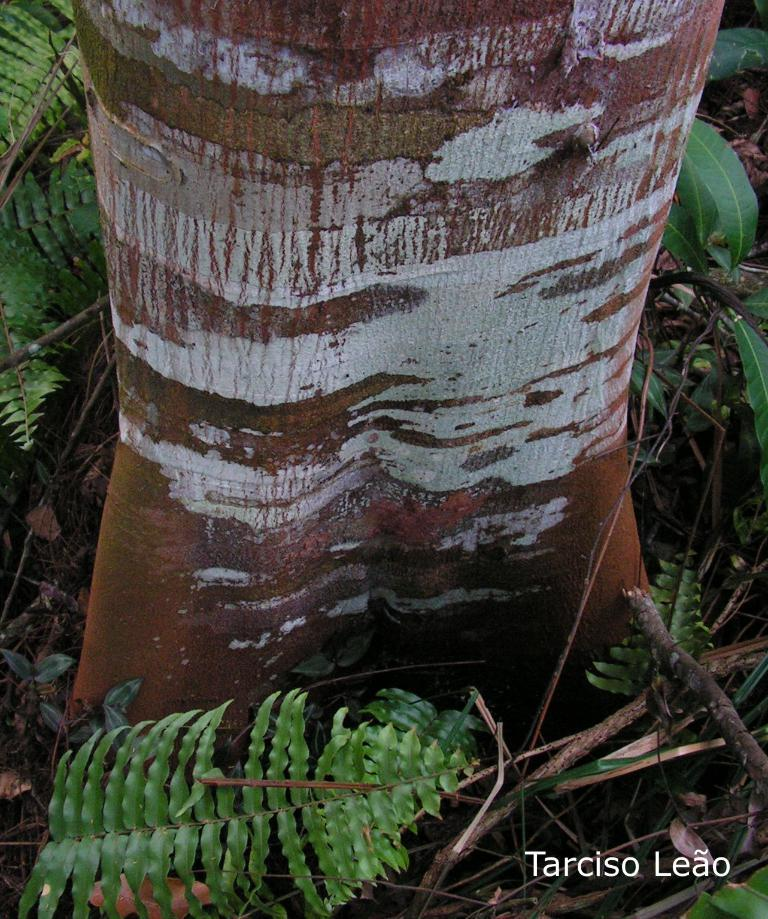What is the main subject in the foreground of the image? There is a trunk in the foreground of the image. What type of vegetation is present around the trunk? There are leaves and dry stems around the trunk. Where is the kitty playing with the cabbage in the image? There is no kitty or cabbage present in the image; it only features a trunk with leaves and dry stems around it. 